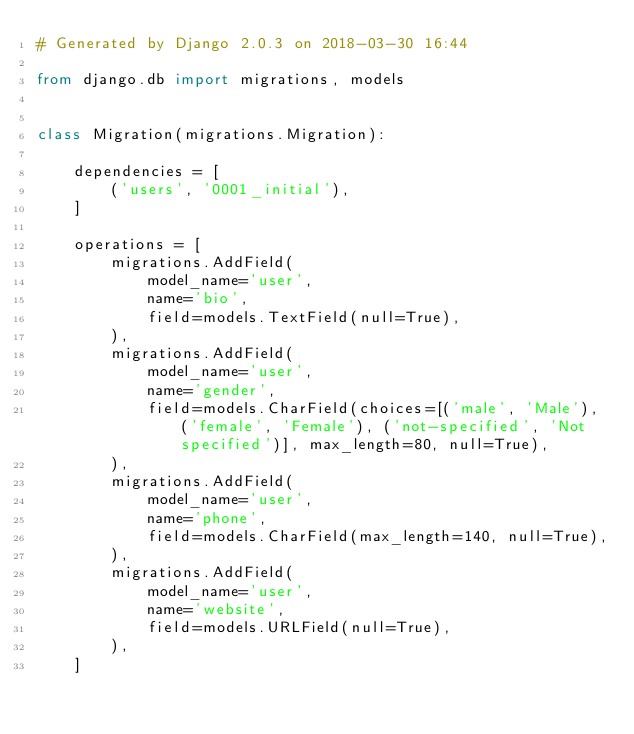<code> <loc_0><loc_0><loc_500><loc_500><_Python_># Generated by Django 2.0.3 on 2018-03-30 16:44

from django.db import migrations, models


class Migration(migrations.Migration):

    dependencies = [
        ('users', '0001_initial'),
    ]

    operations = [
        migrations.AddField(
            model_name='user',
            name='bio',
            field=models.TextField(null=True),
        ),
        migrations.AddField(
            model_name='user',
            name='gender',
            field=models.CharField(choices=[('male', 'Male'), ('female', 'Female'), ('not-specified', 'Not specified')], max_length=80, null=True),
        ),
        migrations.AddField(
            model_name='user',
            name='phone',
            field=models.CharField(max_length=140, null=True),
        ),
        migrations.AddField(
            model_name='user',
            name='website',
            field=models.URLField(null=True),
        ),
    ]
</code> 